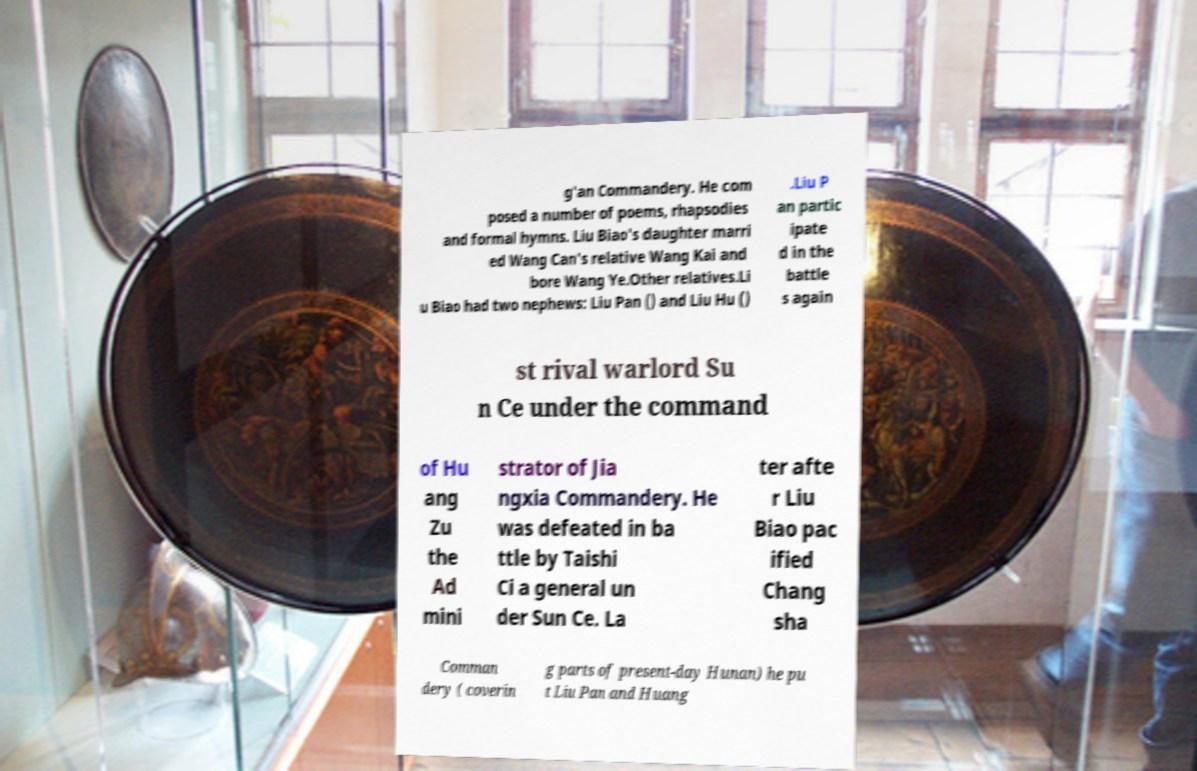I need the written content from this picture converted into text. Can you do that? g'an Commandery. He com posed a number of poems, rhapsodies and formal hymns. Liu Biao's daughter marri ed Wang Can's relative Wang Kai and bore Wang Ye.Other relatives.Li u Biao had two nephews: Liu Pan () and Liu Hu () .Liu P an partic ipate d in the battle s again st rival warlord Su n Ce under the command of Hu ang Zu the Ad mini strator of Jia ngxia Commandery. He was defeated in ba ttle by Taishi Ci a general un der Sun Ce. La ter afte r Liu Biao pac ified Chang sha Comman dery ( coverin g parts of present-day Hunan) he pu t Liu Pan and Huang 